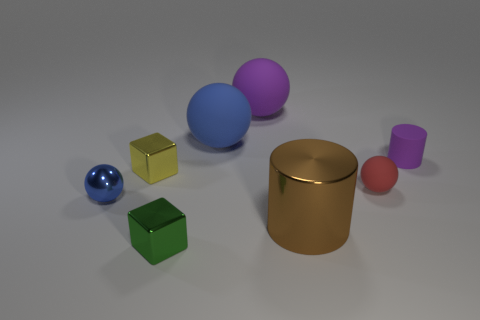What size is the metal cube that is to the left of the small cube in front of the tiny blue metal thing?
Your answer should be very brief. Small. There is a purple thing in front of the blue object that is behind the small red thing that is behind the tiny blue shiny thing; what is its size?
Your answer should be compact. Small. There is a metal object that is to the right of the tiny green cube; is its shape the same as the tiny metal thing that is in front of the big brown metal thing?
Your response must be concise. No. What number of other objects are there of the same color as the metallic cylinder?
Make the answer very short. 0. Is the size of the purple object that is on the left side of the red sphere the same as the purple matte cylinder?
Provide a succinct answer. No. Is the material of the small sphere that is right of the blue shiny object the same as the blue thing in front of the tiny purple thing?
Give a very brief answer. No. Is there another metallic object that has the same size as the brown metal object?
Provide a succinct answer. No. What shape is the big thing to the right of the purple ball that is behind the tiny ball on the right side of the yellow object?
Make the answer very short. Cylinder. Is the number of big rubber spheres in front of the large blue rubber ball greater than the number of cylinders?
Ensure brevity in your answer.  No. Is there another object that has the same shape as the yellow object?
Ensure brevity in your answer.  Yes. 